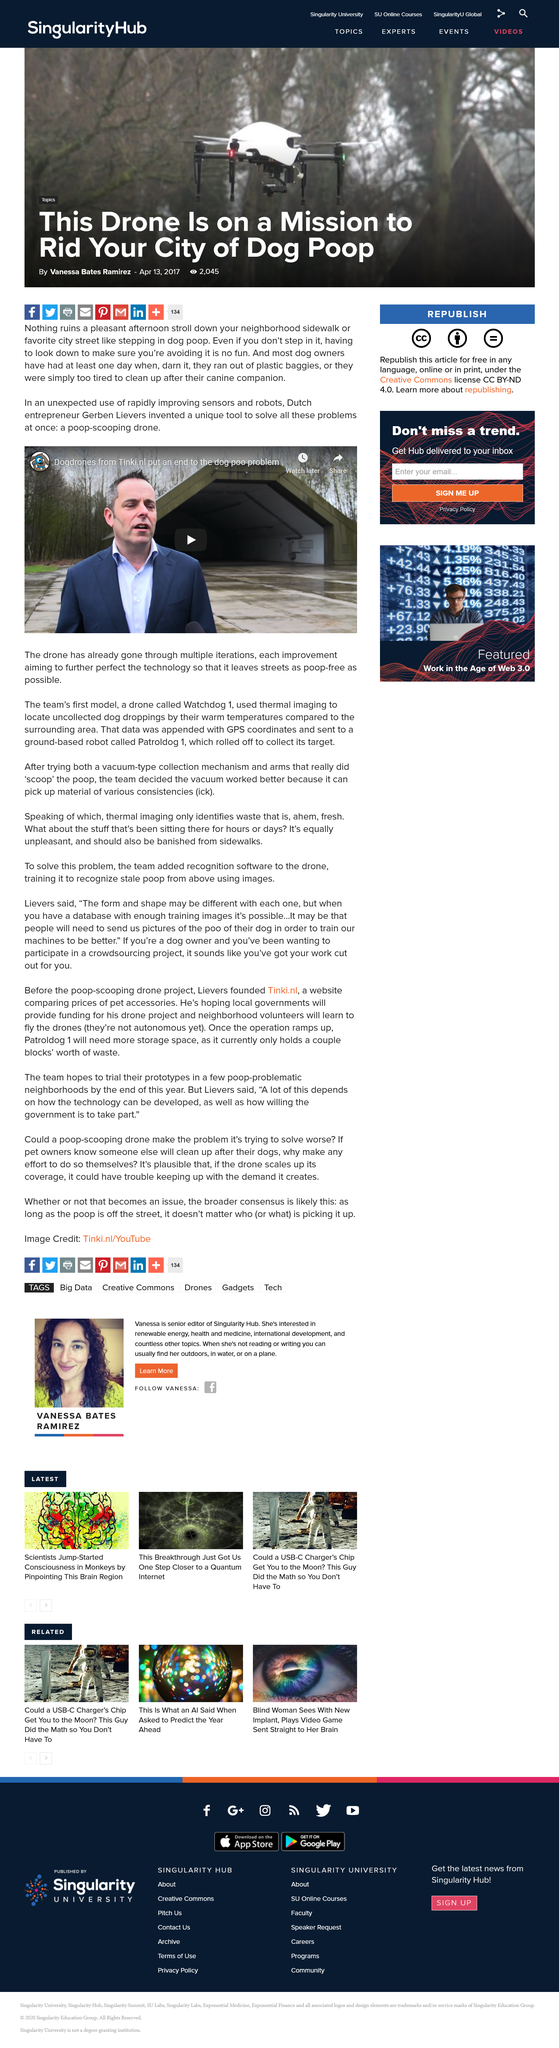Draw attention to some important aspects in this diagram. Gerben Lievers is from the Netherlands, also known as Holland. Gerben Lievers, an entrepreneur, has invented a tool that solves the problem of picking up dog poop, thus revolutionizing the way dog owners dispose of their pets' waste and making the world a cleaner and healthier place for both dogs and humans. The act of stepping in dog poop while engaging in a pleasant afternoon stroll in one's neighborhood is sure to ruin the experience. 